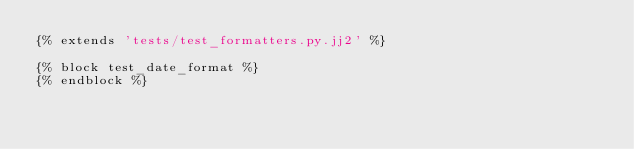<code> <loc_0><loc_0><loc_500><loc_500><_Python_>{% extends 'tests/test_formatters.py.jj2' %}

{% block test_date_format %}
{% endblock %}
</code> 